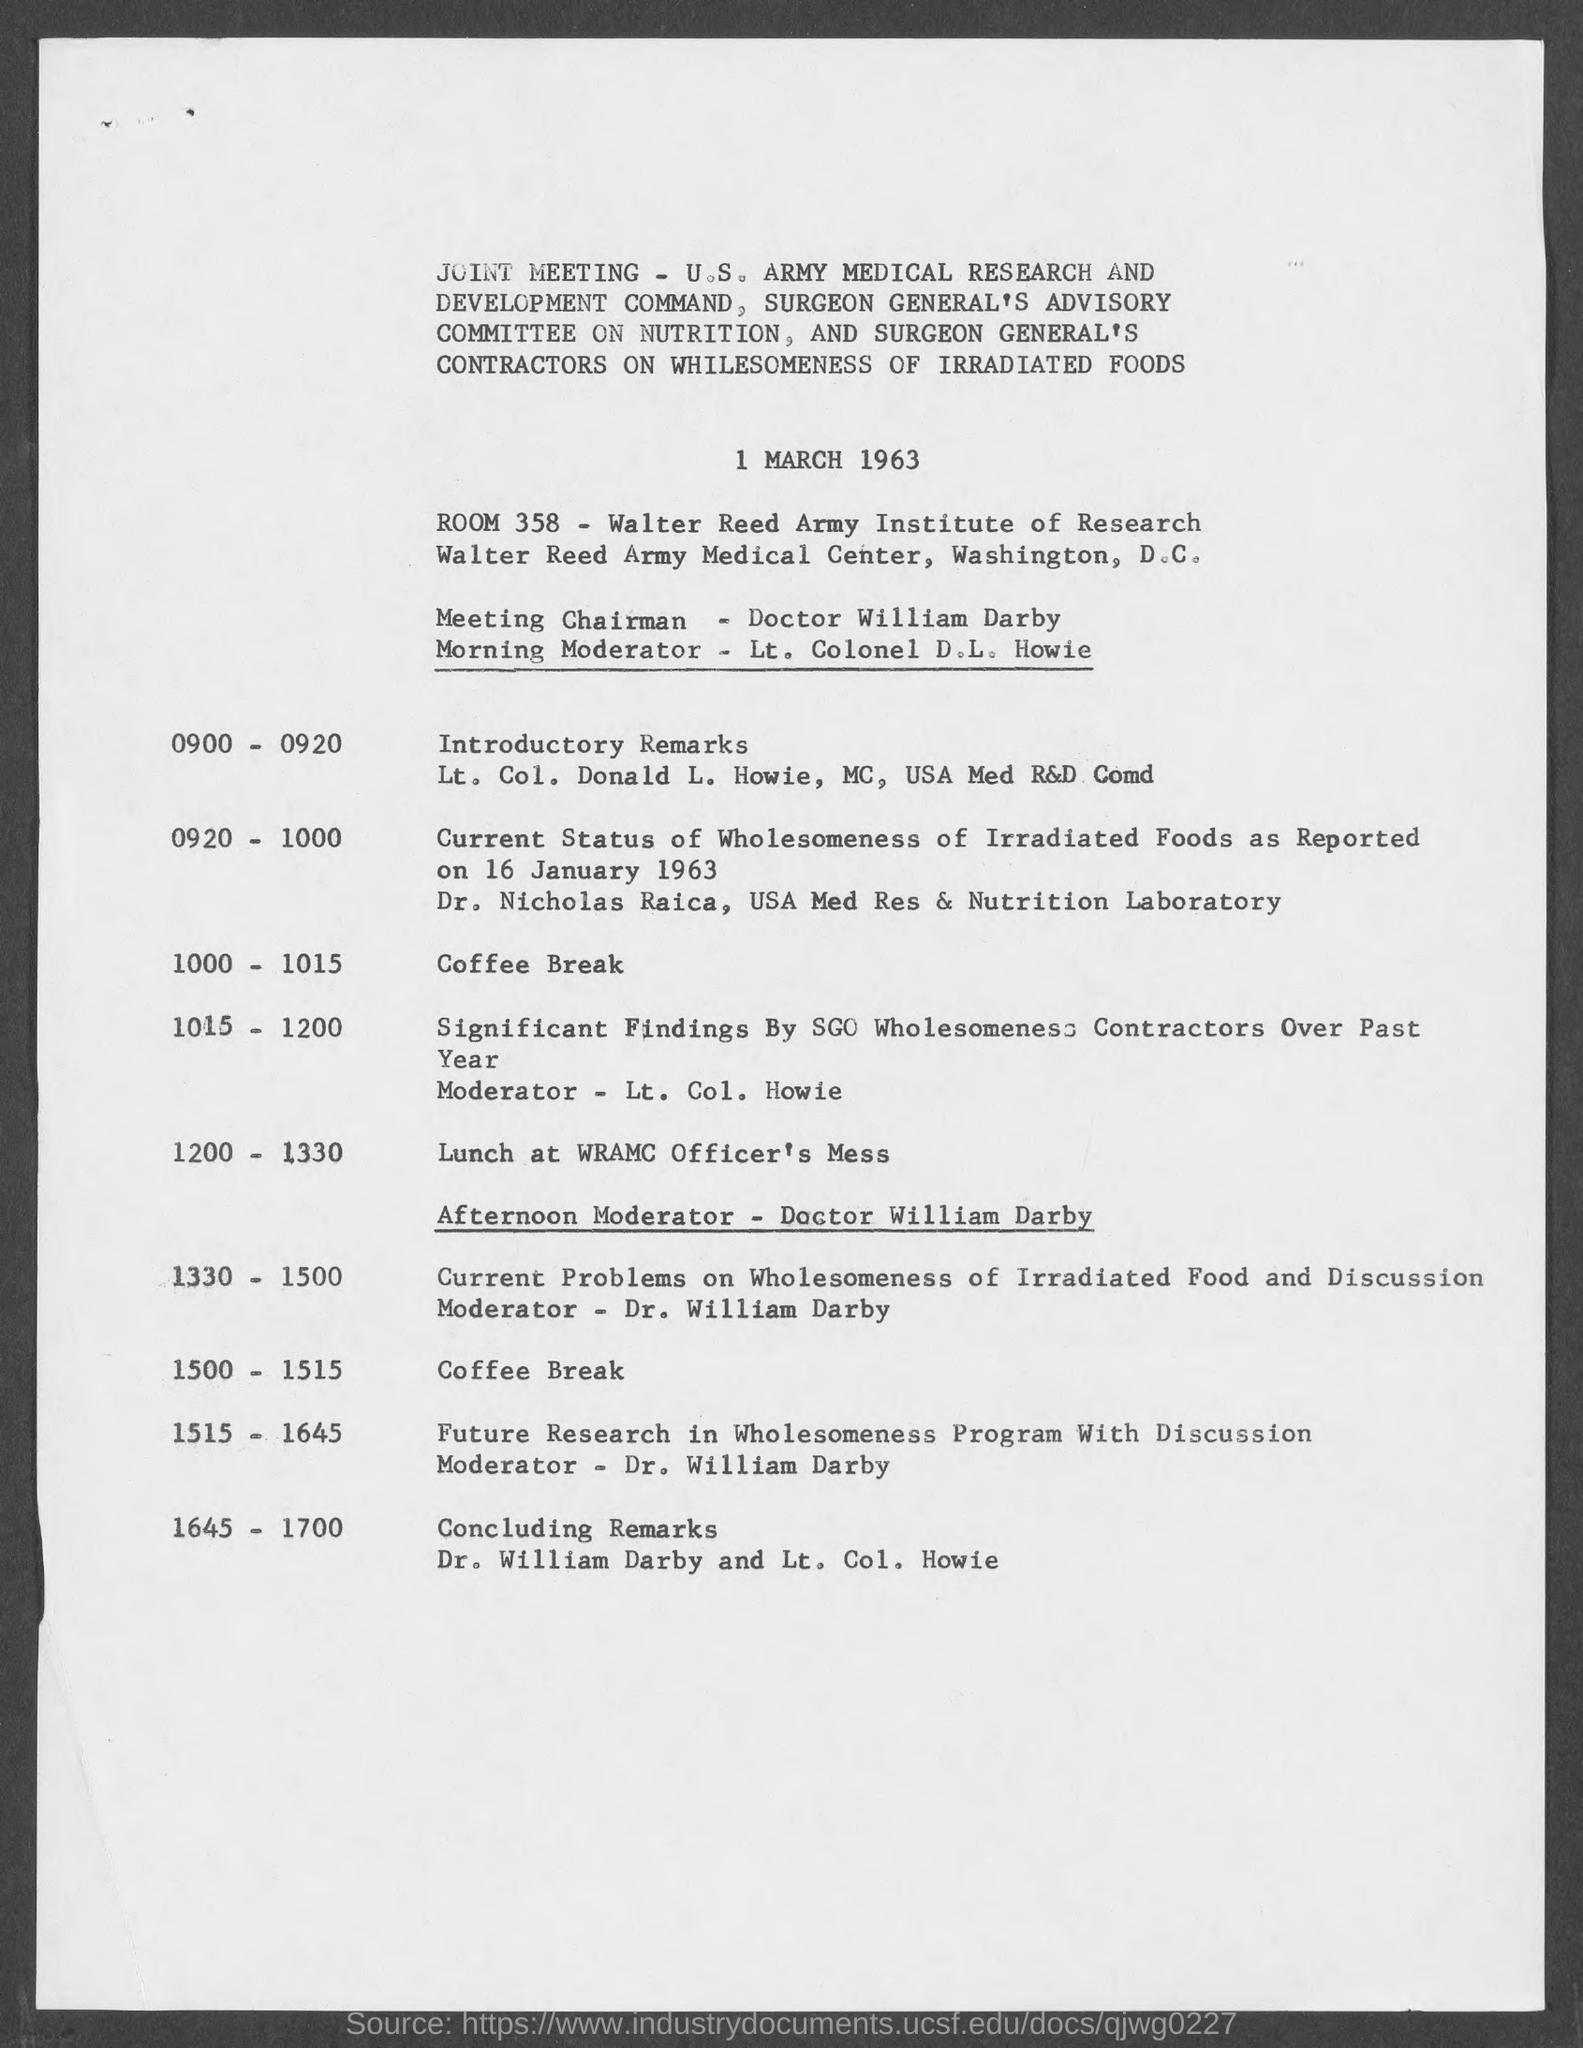When is the joint meeting held?
Your answer should be compact. 1 march 1963. What is the room number?
Offer a terse response. 358. Who is the meeting chairman?
Ensure brevity in your answer.  Doctor william darby. Who is the morning moderator?
Offer a terse response. Lt. colonel d.l. howie. Who is the moderator for afternoon?
Your answer should be compact. Doctor william darby. What is the venue for lunch?
Your answer should be very brief. Wramc officer's mess. 